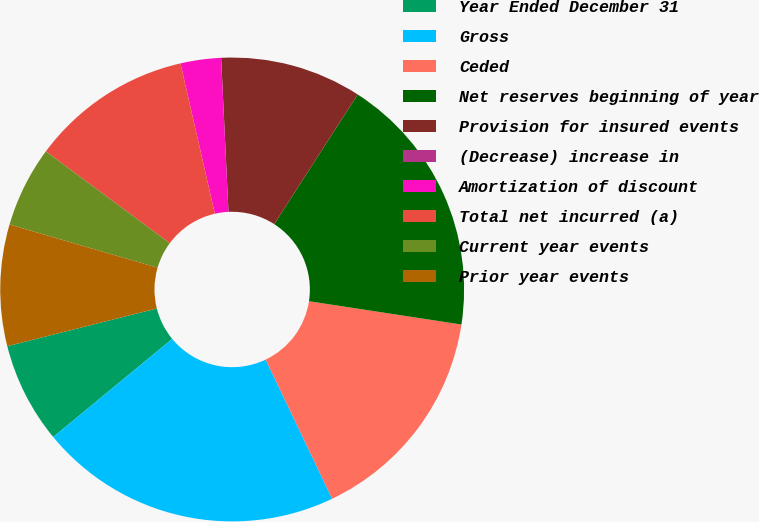<chart> <loc_0><loc_0><loc_500><loc_500><pie_chart><fcel>Year Ended December 31<fcel>Gross<fcel>Ceded<fcel>Net reserves beginning of year<fcel>Provision for insured events<fcel>(Decrease) increase in<fcel>Amortization of discount<fcel>Total net incurred (a)<fcel>Current year events<fcel>Prior year events<nl><fcel>7.04%<fcel>21.12%<fcel>15.49%<fcel>18.31%<fcel>9.86%<fcel>0.0%<fcel>2.82%<fcel>11.27%<fcel>5.63%<fcel>8.45%<nl></chart> 